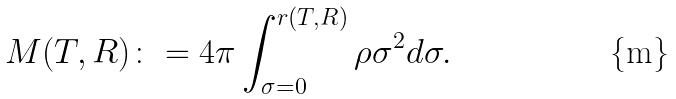Convert formula to latex. <formula><loc_0><loc_0><loc_500><loc_500>M ( T , R ) \colon = 4 \pi \int _ { \sigma = 0 } ^ { r ( T , R ) } \rho \sigma ^ { 2 } d \sigma .</formula> 